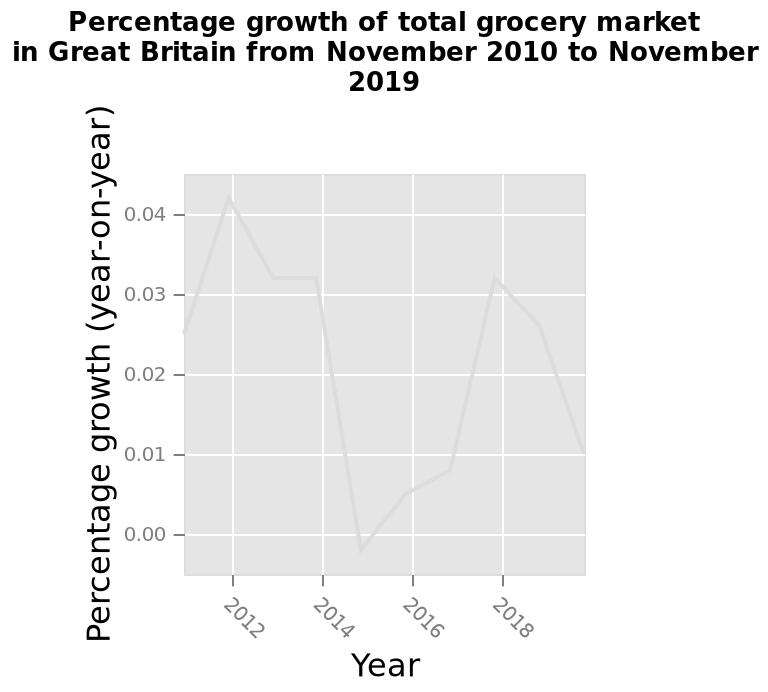<image>
What period of time does the line graph cover? The line graph covers the period from November 2010 to November 2019. What is represented on the y-axis of the line graph? The y-axis of the line graph represents the percentage growth (year-on-year) of the total grocery market. What is plotted along the x-axis of the line graph?  The x-axis of the line graph represents the years from November 2010 to November 2019. 